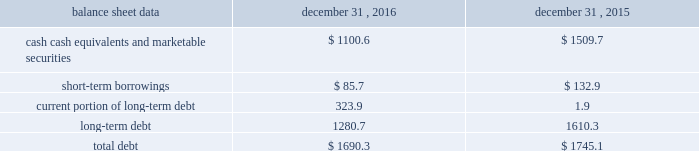Management 2019s discussion and analysis of financial condition and results of operations 2013 ( continued ) ( amounts in millions , except per share amounts ) the effect of foreign exchange rate changes on cash and cash equivalents included in the consolidated statements of cash flows resulted in a decrease of $ 156.1 in 2015 .
The decrease was primarily a result of the u.s .
Dollar being stronger than several foreign currencies , including the australian dollar , brazilian real , canadian dollar , euro and south african rand as of december 31 , 2015 compared to december 31 , 2014. .
Liquidity outlook we expect our cash flow from operations , cash and cash equivalents to be sufficient to meet our anticipated operating requirements at a minimum for the next twelve months .
We also have a committed corporate credit facility as well as uncommitted facilities available to support our operating needs .
We continue to maintain a disciplined approach to managing liquidity , with flexibility over significant uses of cash , including our capital expenditures , cash used for new acquisitions , our common stock repurchase program and our common stock dividends .
From time to time , we evaluate market conditions and financing alternatives for opportunities to raise additional funds or otherwise improve our liquidity profile , enhance our financial flexibility and manage market risk .
Our ability to access the capital markets depends on a number of factors , which include those specific to us , such as our credit rating , and those related to the financial markets , such as the amount or terms of available credit .
There can be no guarantee that we would be able to access new sources of liquidity on commercially reasonable terms , or at all .
Funding requirements our most significant funding requirements include our operations , non-cancelable operating lease obligations , capital expenditures , acquisitions , common stock dividends , taxes and debt service .
Additionally , we may be required to make payments to minority shareholders in certain subsidiaries if they exercise their options to sell us their equity interests .
Notable funding requirements include : 2022 debt service 2013 our 2.25% ( 2.25 % ) senior notes in aggregate principal amount of $ 300.0 mature on november 15 , 2017 , and a $ 22.6 note classified within our other notes payable is due on june 30 , 2017 .
We expect to use available cash to fund the retirement of the outstanding notes upon maturity .
The remainder of our debt is primarily long-term , with maturities scheduled through 2024 .
See the table below for the maturity schedule of our long-term debt .
2022 acquisitions 2013 we paid cash of $ 52.1 , net of cash acquired of $ 13.6 , for acquisitions completed in 2016 .
We also paid $ 0.5 in up-front payments and $ 59.3 in deferred payments for prior-year acquisitions as well as ownership increases in our consolidated subsidiaries .
In addition to potential cash expenditures for new acquisitions , we expect to pay approximately $ 77.0 in 2017 related to prior-year acquisitions .
We may also be required to pay approximately $ 31.0 in 2017 related to put options held by minority shareholders if exercised .
We will continue to evaluate strategic opportunities to grow and continue to strengthen our market position , particularly in our digital and marketing services offerings , and to expand our presence in high-growth and key strategic world markets .
2022 dividends 2013 during 2016 , we paid four quarterly cash dividends of $ 0.15 per share on our common stock , which corresponded to aggregate dividend payments of $ 238.4 .
On february 10 , 2017 , we announced that our board of directors ( the 201cboard 201d ) had declared a common stock cash dividend of $ 0.18 per share , payable on march 15 , 2017 to holders of record as of the close of business on march 1 , 2017 .
Assuming we pay a quarterly dividend of $ 0.18 per share and there is no significant change in the number of outstanding shares as of december 31 , 2016 , we would expect to pay approximately $ 280.0 over the next twelve months. .
How much has cash equivalents and marketable securities decreased from 2014 to 2016? 
Rationale: to find the amount of cash equivalent and marketable securities in 2014 , one needs to add the amount that was given in line 1 by 2015 . then to find the percentage difference one will subtract 2014 by 2016 and then divide that solution by 2014 .
Computations: (((1509.7 + 156.1) - 1100.6) / (1509.7 + 156.1))
Answer: 0.3393. 